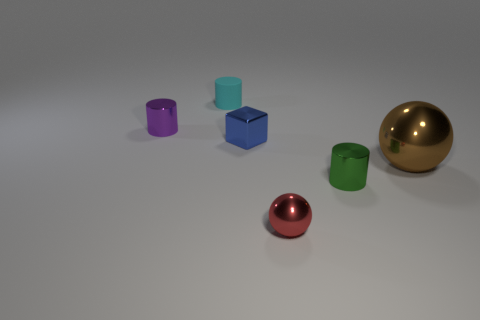Add 3 blue things. How many objects exist? 9 Subtract all blocks. How many objects are left? 5 Add 1 brown spheres. How many brown spheres are left? 2 Add 2 big blue metallic things. How many big blue metallic things exist? 2 Subtract 0 green cubes. How many objects are left? 6 Subtract all tiny red balls. Subtract all large brown shiny spheres. How many objects are left? 4 